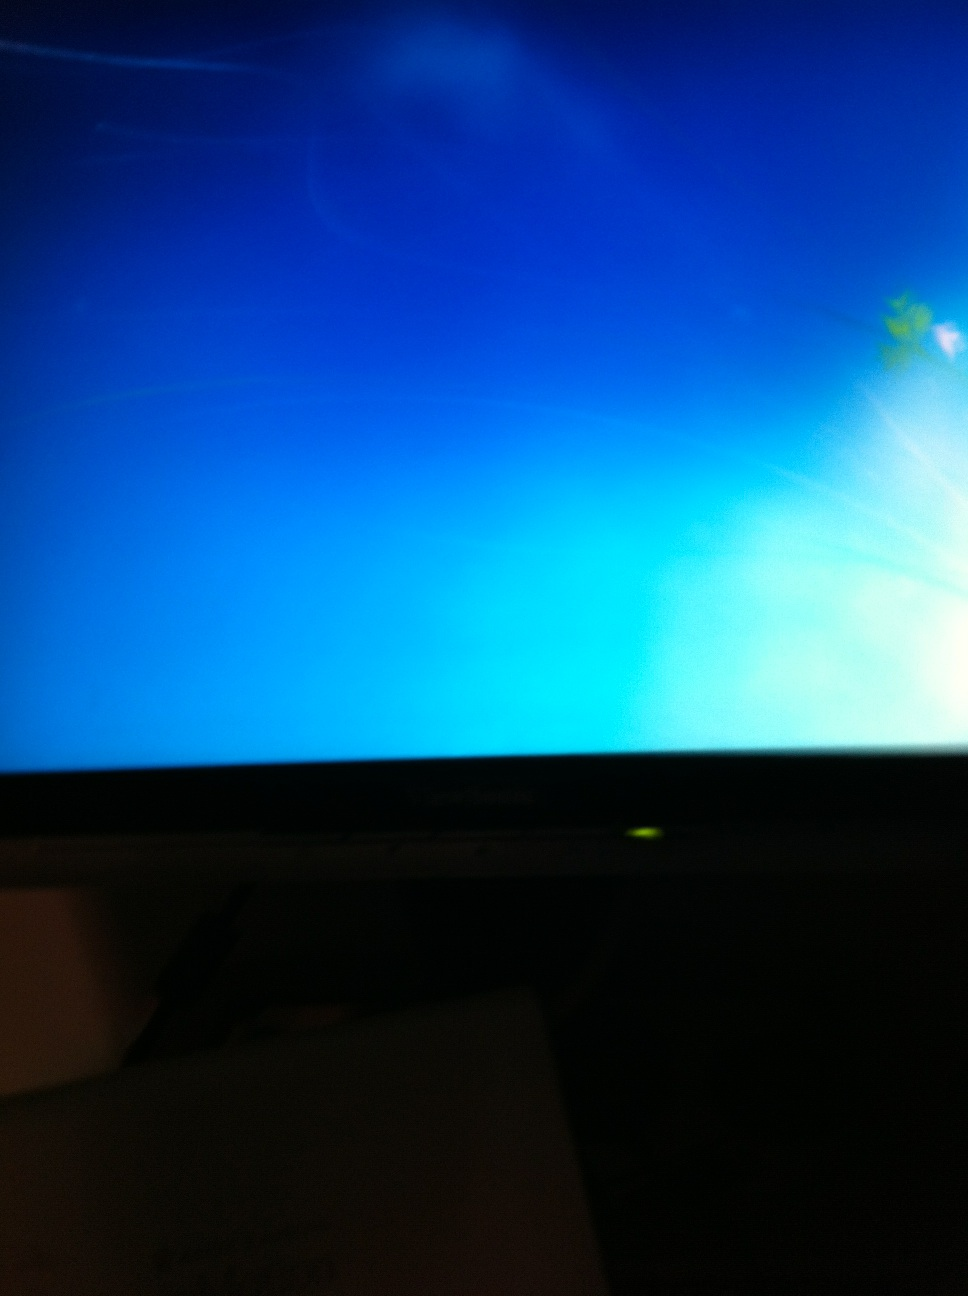Can you guide me on what I should do if my computer doesn't start? Certainly! If your computer isn't starting, begin by ensuring all cables are properly connected and that your monitor is powered on. Then, try performing a hard reboot by holding down the power button for 10 seconds. If this does not work, attempt to start the computer in safe mode, which can help diagnose software-related issues. If you have a recovery drive or installation media, you can use it to repair startup problems. Remember to check for any beeping sounds when you turn on the PC, as these can indicate hardware issues. 